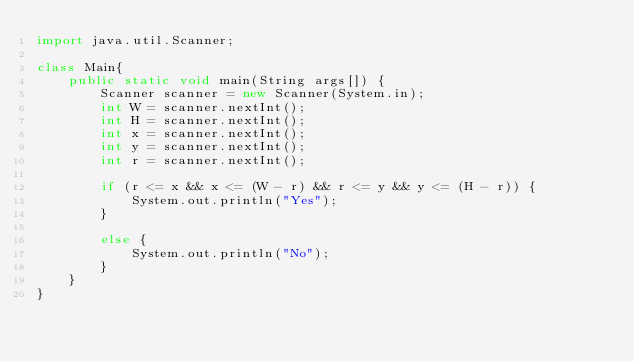Convert code to text. <code><loc_0><loc_0><loc_500><loc_500><_Java_>import java.util.Scanner;

class Main{
	public static void main(String args[]) {
        Scanner scanner = new Scanner(System.in);
        int W = scanner.nextInt();
        int H = scanner.nextInt();
        int x = scanner.nextInt();
        int y = scanner.nextInt();
        int r = scanner.nextInt();

        if (r <= x && x <= (W - r) && r <= y && y <= (H - r)) {
        	System.out.println("Yes");
        }

        else {
        	System.out.println("No");
        }
	}
}
</code> 